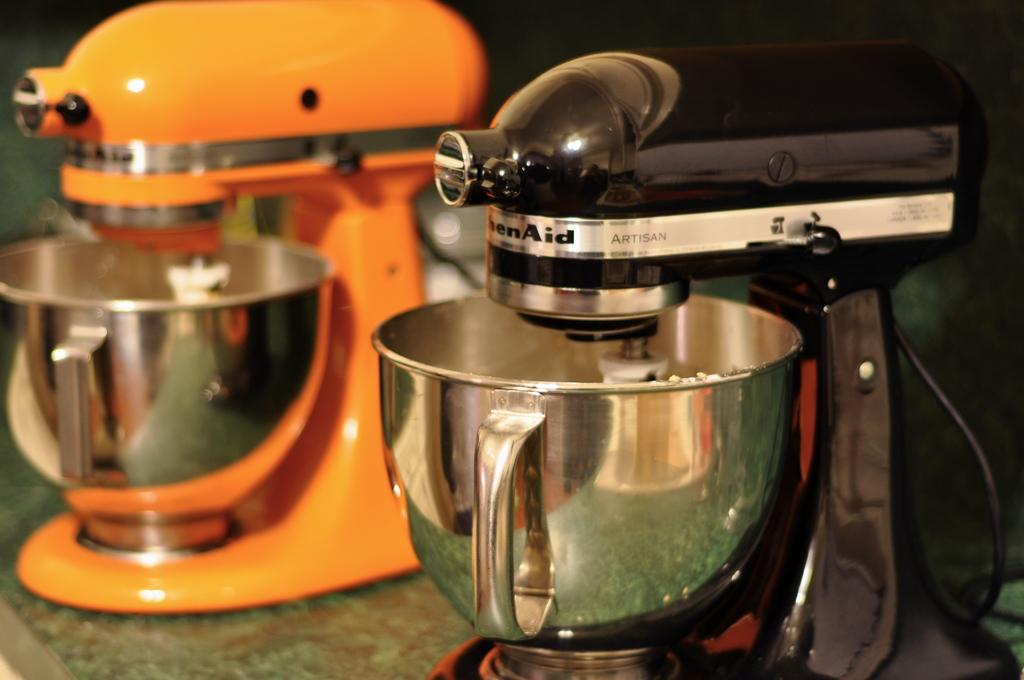What's written after kitchenaid on the closest mixer?
Give a very brief answer. Artisan. 